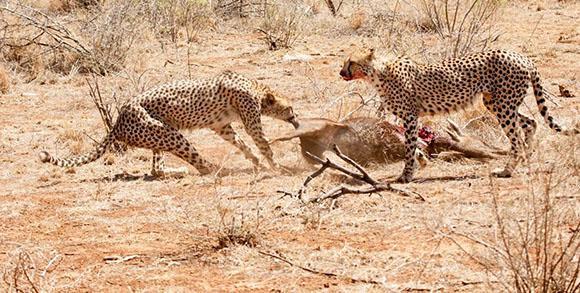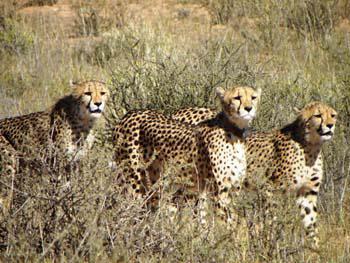The first image is the image on the left, the second image is the image on the right. Examine the images to the left and right. Is the description "In at least one image there is a single leopard whose facing is left forward." accurate? Answer yes or no. No. The first image is the image on the left, the second image is the image on the right. For the images displayed, is the sentence "One image contains exactly one cheetah, which faces the camera, and the other image contains cheetahs with overlapping bodies." factually correct? Answer yes or no. No. 